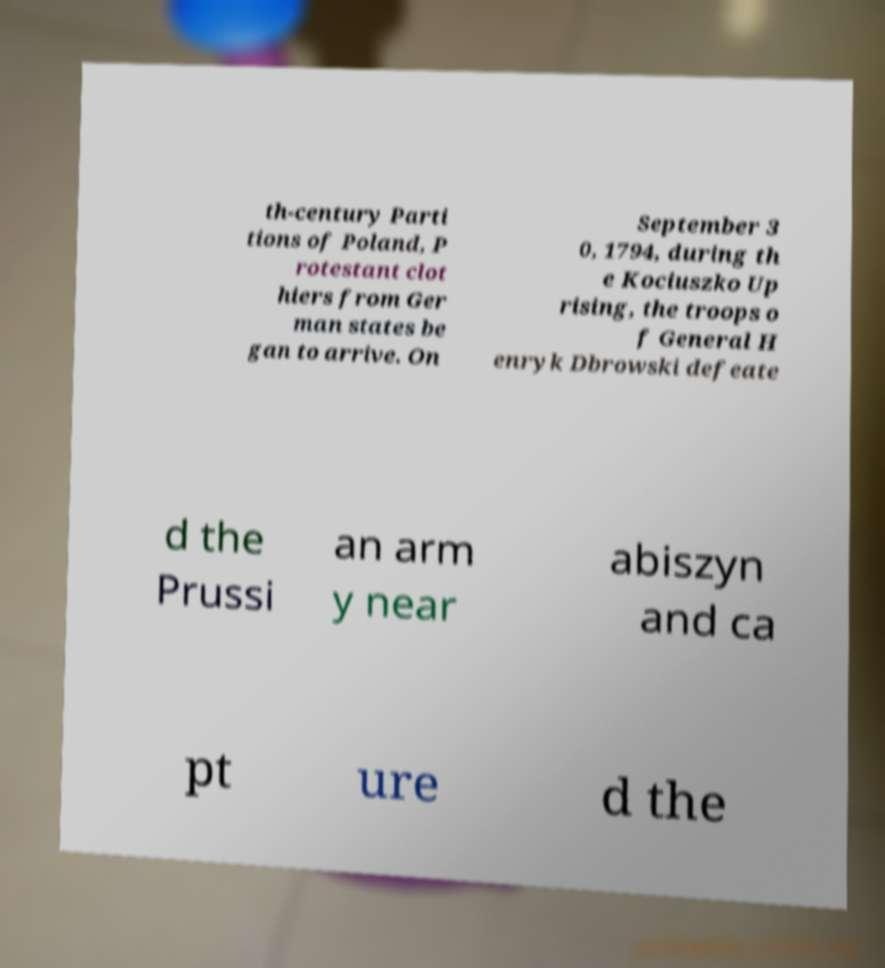Could you extract and type out the text from this image? th-century Parti tions of Poland, P rotestant clot hiers from Ger man states be gan to arrive. On September 3 0, 1794, during th e Kociuszko Up rising, the troops o f General H enryk Dbrowski defeate d the Prussi an arm y near abiszyn and ca pt ure d the 